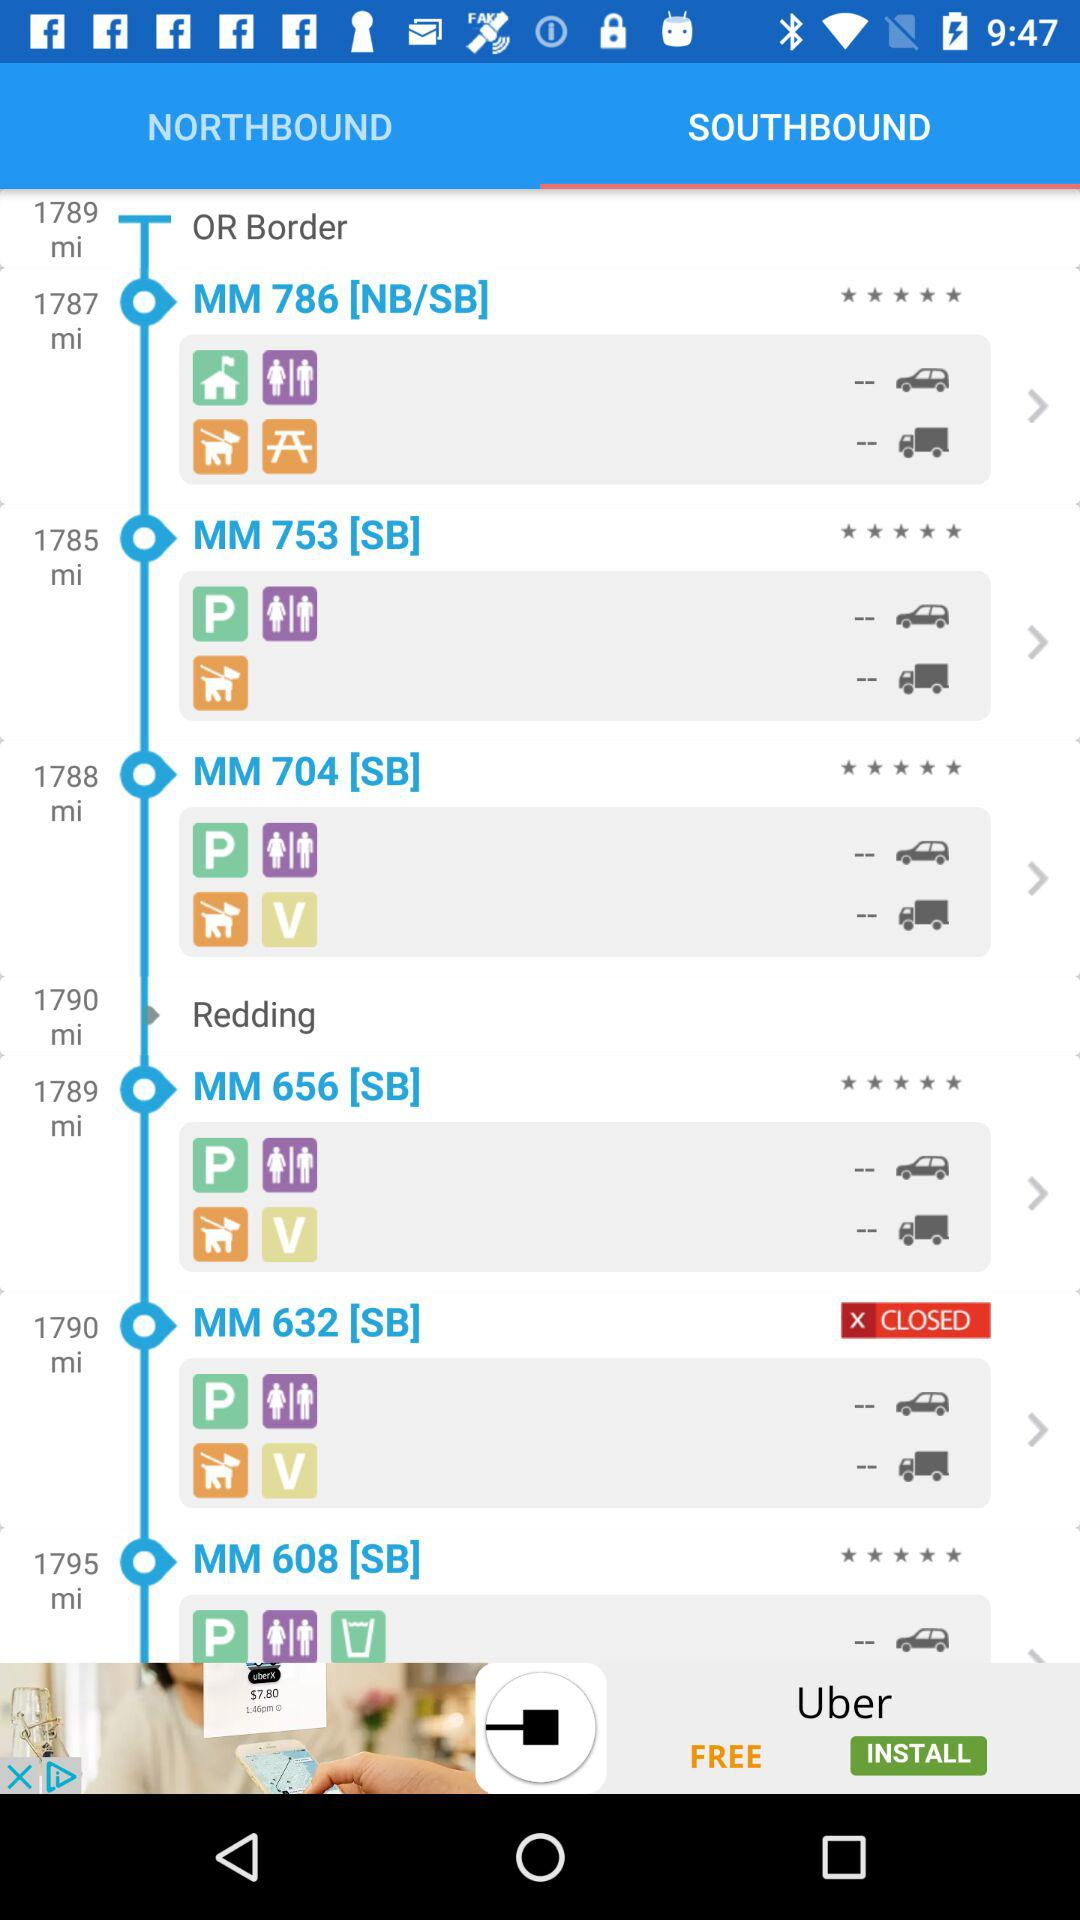How far away is MM 608 [SB]? MM 608 [SB] is 1795 miles away. 